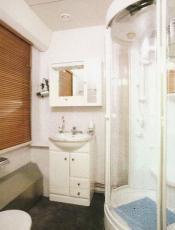How many dogs are there?
Give a very brief answer. 0. 